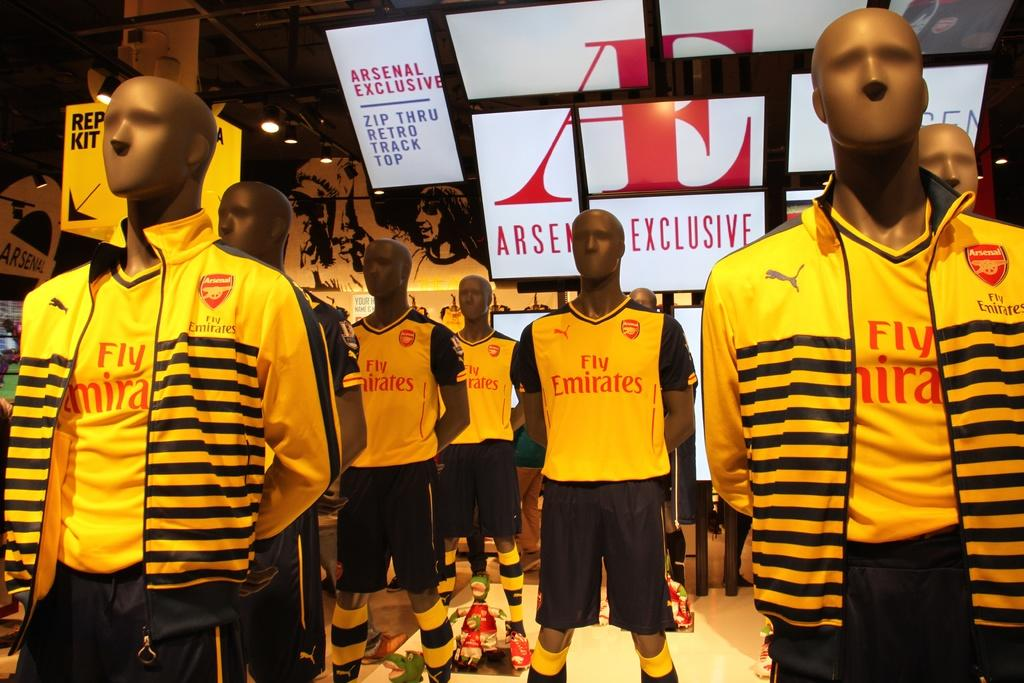<image>
Describe the image concisely. Mannequins wearing yellow and black apparel with Emirates logo. 